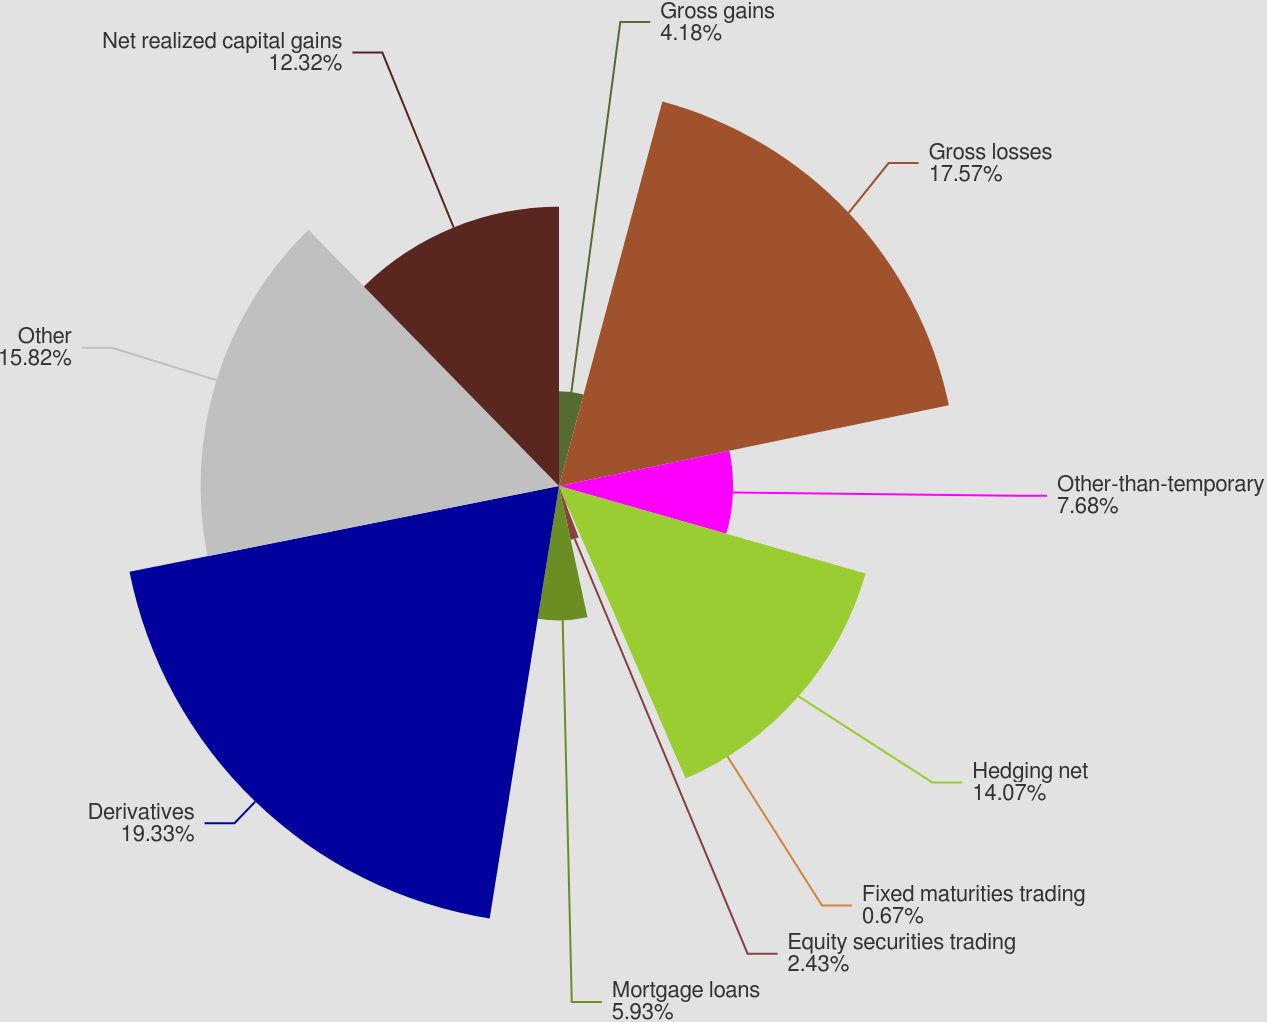<chart> <loc_0><loc_0><loc_500><loc_500><pie_chart><fcel>Gross gains<fcel>Gross losses<fcel>Other-than-temporary<fcel>Hedging net<fcel>Fixed maturities trading<fcel>Equity securities trading<fcel>Mortgage loans<fcel>Derivatives<fcel>Other<fcel>Net realized capital gains<nl><fcel>4.18%<fcel>17.57%<fcel>7.68%<fcel>14.07%<fcel>0.67%<fcel>2.43%<fcel>5.93%<fcel>19.33%<fcel>15.82%<fcel>12.32%<nl></chart> 